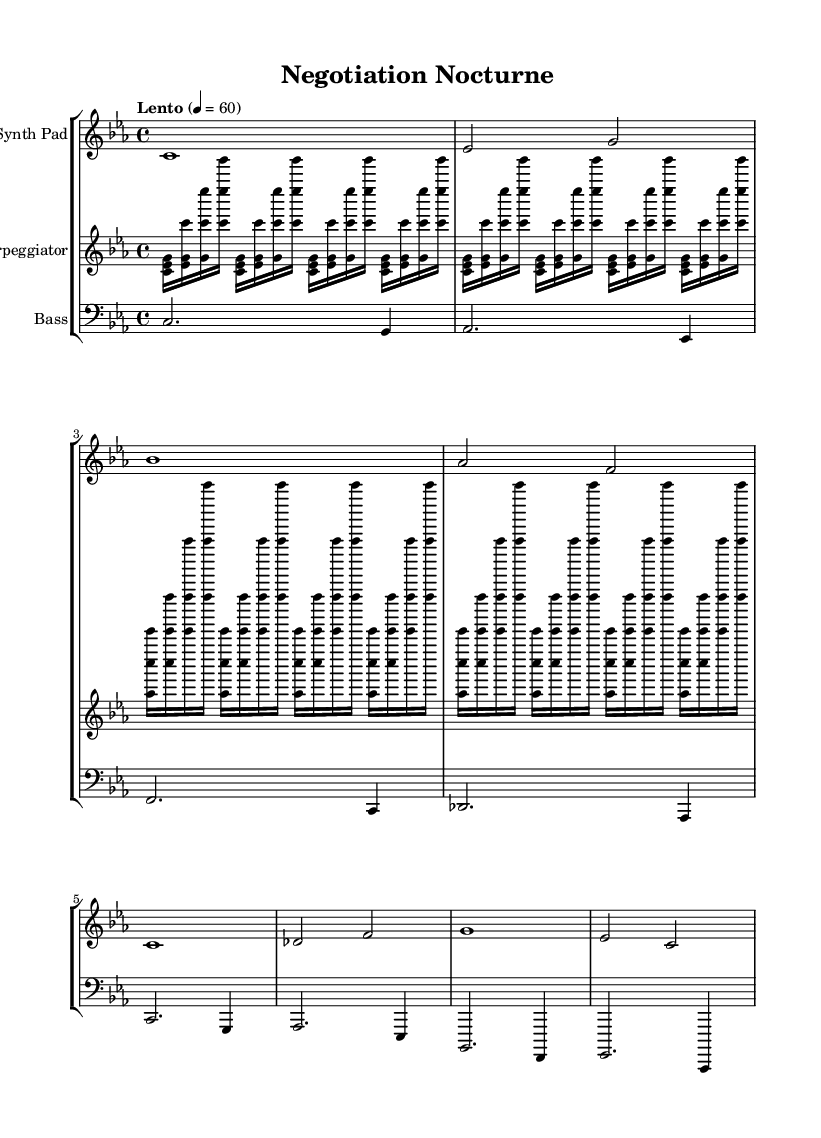What is the key signature of this music? The key signature in the staff indicates C minor, as it includes three flats (B flats, E flats, and A flats), which are characteristic of C minor.
Answer: C minor What is the time signature for this piece? The time signature shown at the beginning of the score is 4/4, indicating that there are four beats in each measure, and the quarter note gets one beat.
Answer: 4/4 What is the tempo marking for this piece? The tempo marking indicates "Lento," which means the piece should be played slowly. The metronome setting of 60 denotes the specific beats per minute for this tempo.
Answer: Lento How many measures are present in the Synth Pad part? The Synth Pad part consists of eight measures based on the visual count of the distinct vertical bar lines that denote the end of each measure in this section.
Answer: 8 Which instrument plays the bass line? The bass line is positioned on a staff marked with the clef "bass;" the bass clef is commonly used for lower-pitched instruments such as bass guitar and bass synthesizers.
Answer: Bass What type of electronic music character is represented by the arpeggiator part? The arpeggiator part consists of repeating notes that create a flowing and rhythmic texture, typical in ambient electronic music, making it suitable for establishing soundscapes.
Answer: Ambient What is the rhythmic pattern in the Synth Pad part? The rhythmic pattern consists mainly of whole and half notes, which emphasizes a sustained, atmospheric quality typical in ambient music.
Answer: Sustained 